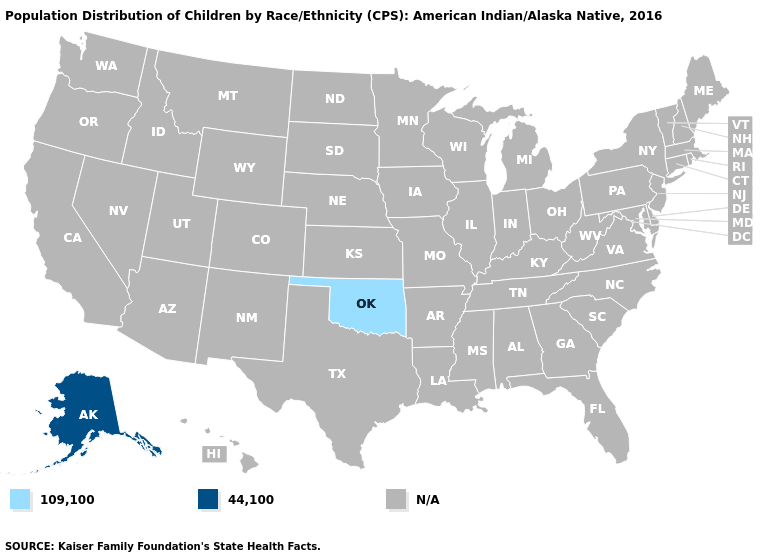Name the states that have a value in the range N/A?
Quick response, please. Alabama, Arizona, Arkansas, California, Colorado, Connecticut, Delaware, Florida, Georgia, Hawaii, Idaho, Illinois, Indiana, Iowa, Kansas, Kentucky, Louisiana, Maine, Maryland, Massachusetts, Michigan, Minnesota, Mississippi, Missouri, Montana, Nebraska, Nevada, New Hampshire, New Jersey, New Mexico, New York, North Carolina, North Dakota, Ohio, Oregon, Pennsylvania, Rhode Island, South Carolina, South Dakota, Tennessee, Texas, Utah, Vermont, Virginia, Washington, West Virginia, Wisconsin, Wyoming. Name the states that have a value in the range N/A?
Write a very short answer. Alabama, Arizona, Arkansas, California, Colorado, Connecticut, Delaware, Florida, Georgia, Hawaii, Idaho, Illinois, Indiana, Iowa, Kansas, Kentucky, Louisiana, Maine, Maryland, Massachusetts, Michigan, Minnesota, Mississippi, Missouri, Montana, Nebraska, Nevada, New Hampshire, New Jersey, New Mexico, New York, North Carolina, North Dakota, Ohio, Oregon, Pennsylvania, Rhode Island, South Carolina, South Dakota, Tennessee, Texas, Utah, Vermont, Virginia, Washington, West Virginia, Wisconsin, Wyoming. What is the lowest value in the USA?
Give a very brief answer. 109,100. What is the lowest value in the USA?
Keep it brief. 109,100. What is the value of Pennsylvania?
Keep it brief. N/A. How many symbols are there in the legend?
Concise answer only. 3. What is the value of Washington?
Keep it brief. N/A. Name the states that have a value in the range 44,100?
Quick response, please. Alaska. Which states have the highest value in the USA?
Quick response, please. Alaska. Name the states that have a value in the range 109,100?
Write a very short answer. Oklahoma. Does Oklahoma have the lowest value in the USA?
Give a very brief answer. Yes. 